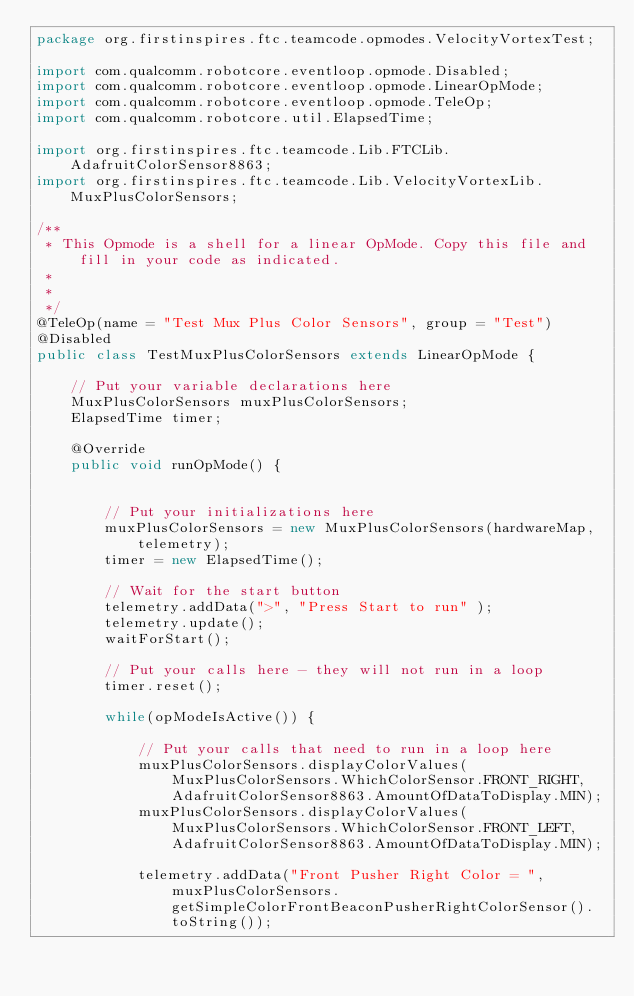Convert code to text. <code><loc_0><loc_0><loc_500><loc_500><_Java_>package org.firstinspires.ftc.teamcode.opmodes.VelocityVortexTest;

import com.qualcomm.robotcore.eventloop.opmode.Disabled;
import com.qualcomm.robotcore.eventloop.opmode.LinearOpMode;
import com.qualcomm.robotcore.eventloop.opmode.TeleOp;
import com.qualcomm.robotcore.util.ElapsedTime;

import org.firstinspires.ftc.teamcode.Lib.FTCLib.AdafruitColorSensor8863;
import org.firstinspires.ftc.teamcode.Lib.VelocityVortexLib.MuxPlusColorSensors;

/**
 * This Opmode is a shell for a linear OpMode. Copy this file and fill in your code as indicated.
 *
 *
 */
@TeleOp(name = "Test Mux Plus Color Sensors", group = "Test")
@Disabled
public class TestMuxPlusColorSensors extends LinearOpMode {

    // Put your variable declarations here
    MuxPlusColorSensors muxPlusColorSensors;
    ElapsedTime timer;

    @Override
    public void runOpMode() {


        // Put your initializations here
        muxPlusColorSensors = new MuxPlusColorSensors(hardwareMap, telemetry);
        timer = new ElapsedTime();
        
        // Wait for the start button
        telemetry.addData(">", "Press Start to run" );
        telemetry.update();
        waitForStart();

        // Put your calls here - they will not run in a loop
        timer.reset();

        while(opModeIsActive()) {

            // Put your calls that need to run in a loop here
            muxPlusColorSensors.displayColorValues(MuxPlusColorSensors.WhichColorSensor.FRONT_RIGHT, AdafruitColorSensor8863.AmountOfDataToDisplay.MIN);
            muxPlusColorSensors.displayColorValues(MuxPlusColorSensors.WhichColorSensor.FRONT_LEFT, AdafruitColorSensor8863.AmountOfDataToDisplay.MIN);

            telemetry.addData("Front Pusher Right Color = ", muxPlusColorSensors.getSimpleColorFrontBeaconPusherRightColorSensor().toString());</code> 